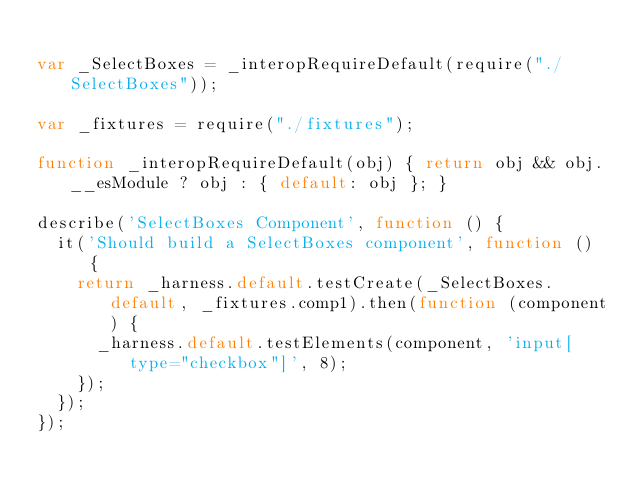<code> <loc_0><loc_0><loc_500><loc_500><_JavaScript_>
var _SelectBoxes = _interopRequireDefault(require("./SelectBoxes"));

var _fixtures = require("./fixtures");

function _interopRequireDefault(obj) { return obj && obj.__esModule ? obj : { default: obj }; }

describe('SelectBoxes Component', function () {
  it('Should build a SelectBoxes component', function () {
    return _harness.default.testCreate(_SelectBoxes.default, _fixtures.comp1).then(function (component) {
      _harness.default.testElements(component, 'input[type="checkbox"]', 8);
    });
  });
});</code> 